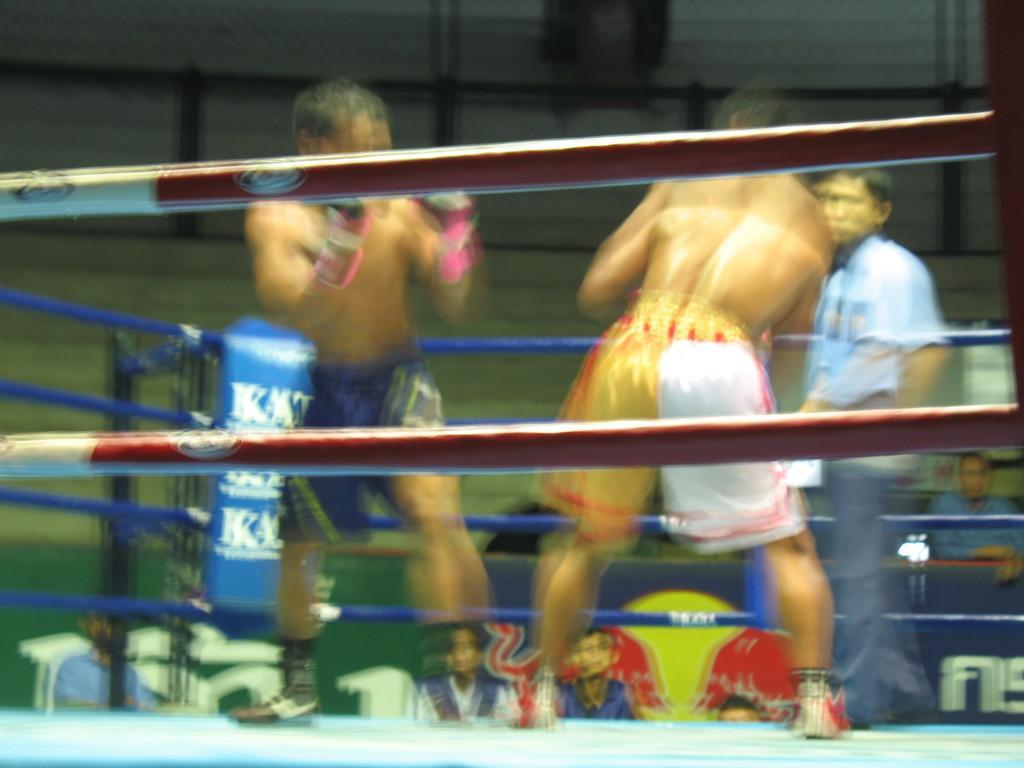How would you summarize this image in a sentence or two? It is a blur image. In this image, we can see a group of people. At the bottom, we can see blue color. Here there are few ropes and poles. 